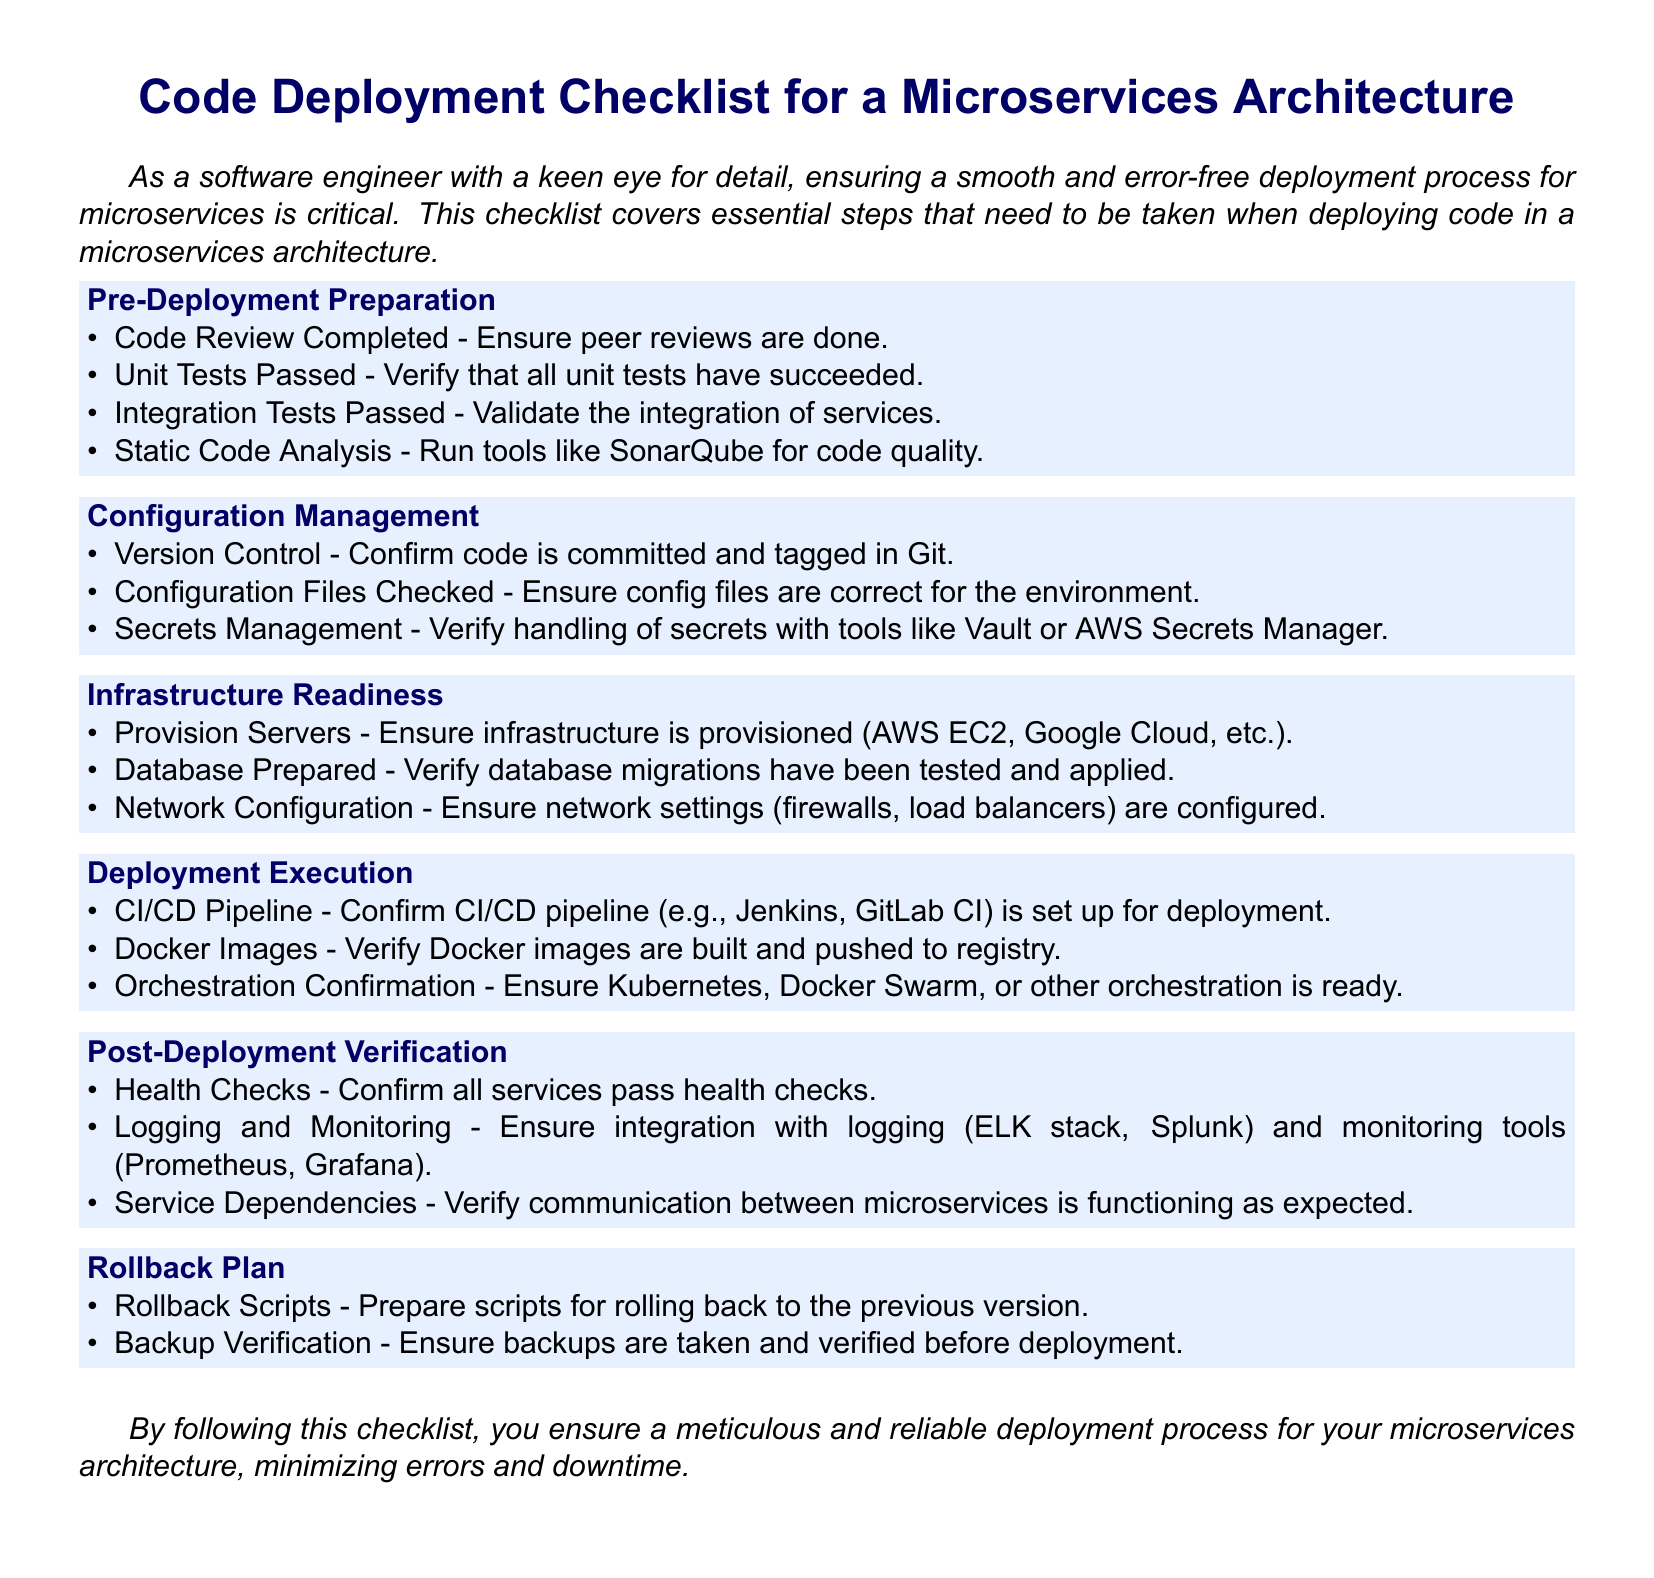What is the first step in the Pre-Deployment Preparation? The checklist begins with ensuring that code reviews are completed.
Answer: Code Review Completed How many categories are in the checklist? The checklist contains six categories.
Answer: Six What tool is suggested for static code analysis? The document mentions using SonarQube for code quality analysis.
Answer: SonarQube What is required to confirm before deployment execution? You must confirm that the CI/CD pipeline is set up for deployment.
Answer: CI/CD Pipeline What should be prepared before deployment in the Rollback Plan? The checklist specifies preparing scripts for rolling back to the previous version.
Answer: Rollback Scripts Which service management tool is recommended for handling secrets? The checklist suggests using tools like Vault or AWS Secrets Manager for secrets management.
Answer: Vault or AWS Secrets Manager 